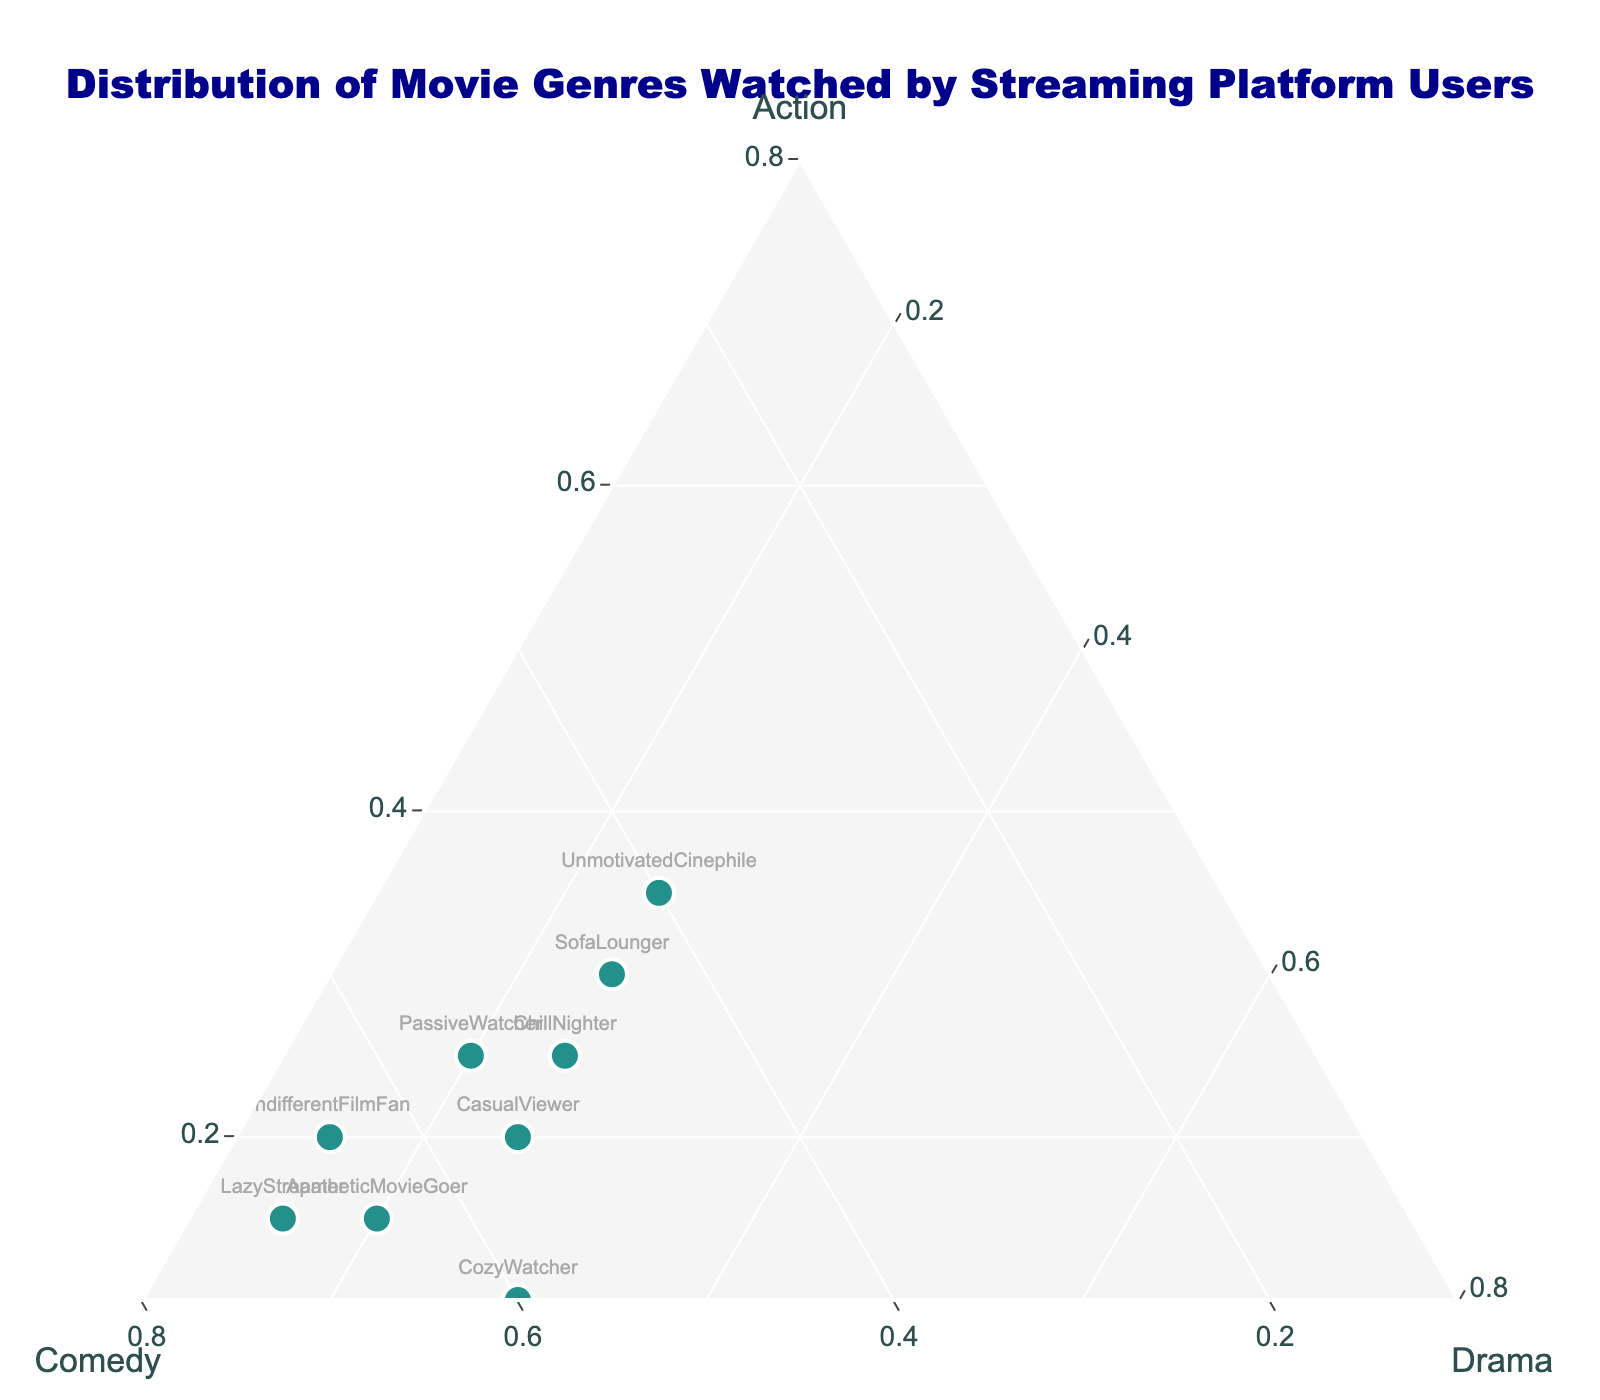What's the title of the ternary plot? The title of the plot is displayed prominently at the top of the figure. It generally gives an overview of what the plot is representing.
Answer: Distribution of Movie Genres Watched by Streaming Platform Users How many users are represented in the plot? The number of data points or markers on the ternary plot represents the number of users. By counting these markers, you can determine the total number of users.
Answer: 10 Which user has watched the highest percentage of action movies? In a ternary plot, users with the highest percentage of a particular genre will be positioned closer to the vertex representing that genre. The user closest to the 'Action' vertex has watched the highest percentage of action movies.
Answer: UnmotivatedCinephile Which platform user has the most balanced viewing habits between action, comedy, and drama? A user with balanced viewing habits will be positioned closer to the center of the ternary plot since they have similar percentages of action, comedy, and drama.
Answer: ChillNighter Who watched the least amount of action movies? The user with the smallest percentage of action movies will be positioned farthest from the 'Action' vertex. By looking at the position farthest from 'Action', we can find this user.
Answer: RelaxedBinger Which user has watched more drama movies, LazyStreamer or PassiveWatcher? By comparing the positions of LazyStreamer and PassiveWatcher along the 'Drama' axis, the user who is closer to the 'Drama' vertex has watched more drama movies.
Answer: CozyWatcher What is the median percentage of comedy movies watched by the users? To find the median percentage of comedy movies, we extract the percentages of comedy movies for all users, then sort these percentages, and find the middle value.
Answer: 60% Who are the users that have watched more than 50% of comedy movies? Users who have watched more than 50% of comedy movies will be positioned farther along the 'Comedy' axis. By locating these users on the ternary plot, we can identify them.
Answer: CozyWatcher, LazyStreamer, CasualViewer, RelaxedBinger, IndifferentFilmFan, ApatheticMovieGoer Is there a user who has watched exactly the same percentage of action and drama movies? By examining the position of each user along the 'Action' and 'Drama' axes, a user who has the same percentage for both genres will be positioned in a manner where their 'Action' and 'Drama' axes' values are equal.
Answer: None Which user has watched the highest total number of movies? The color and size of the marker can indicate the total number of movies watched by each user. The user with the largest and darkest marker on the color scale has watched the highest total number of movies.
Answer: UnmotivatedCinephile 